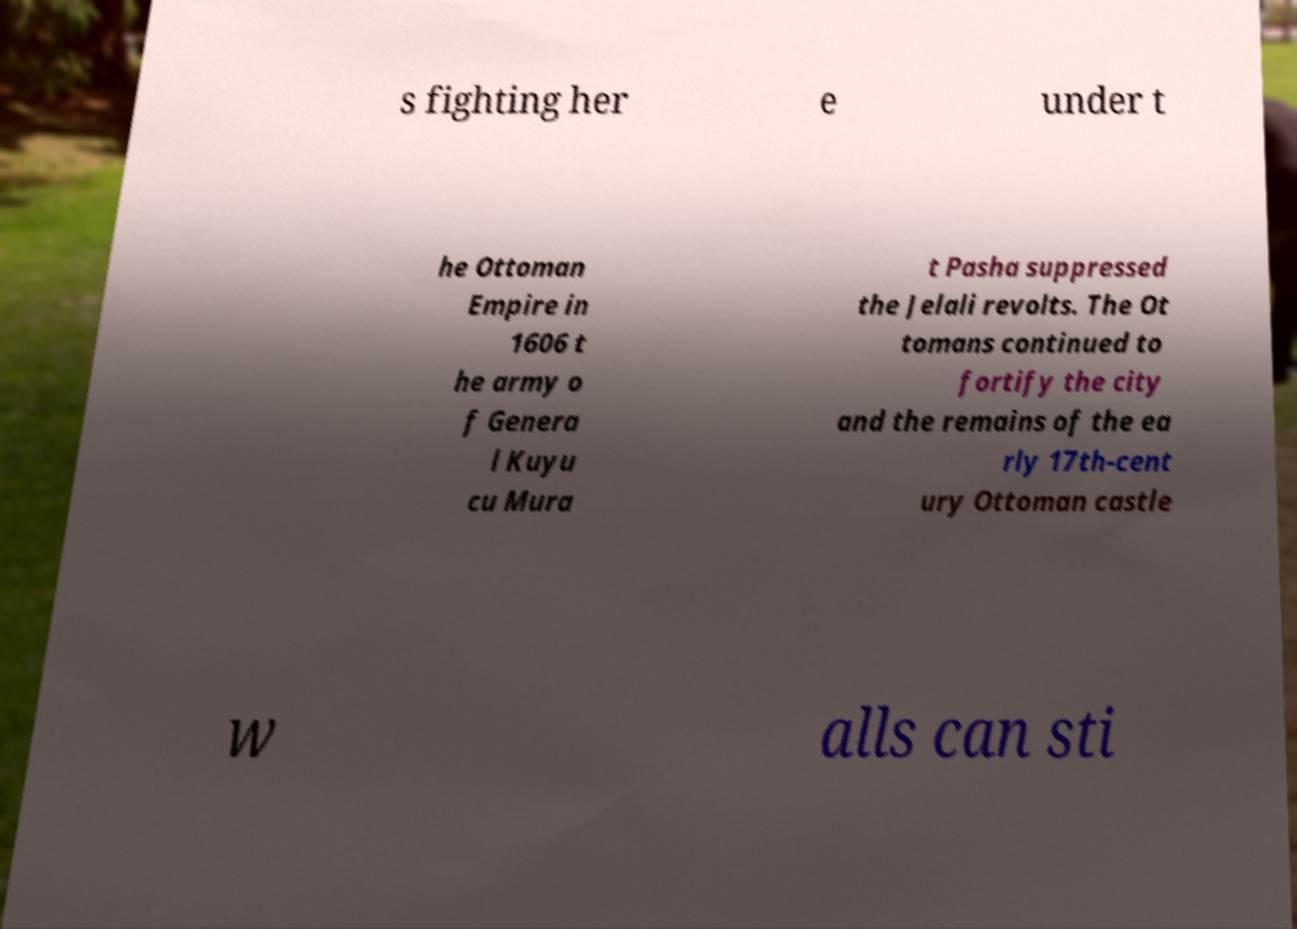Can you read and provide the text displayed in the image?This photo seems to have some interesting text. Can you extract and type it out for me? s fighting her e under t he Ottoman Empire in 1606 t he army o f Genera l Kuyu cu Mura t Pasha suppressed the Jelali revolts. The Ot tomans continued to fortify the city and the remains of the ea rly 17th-cent ury Ottoman castle w alls can sti 